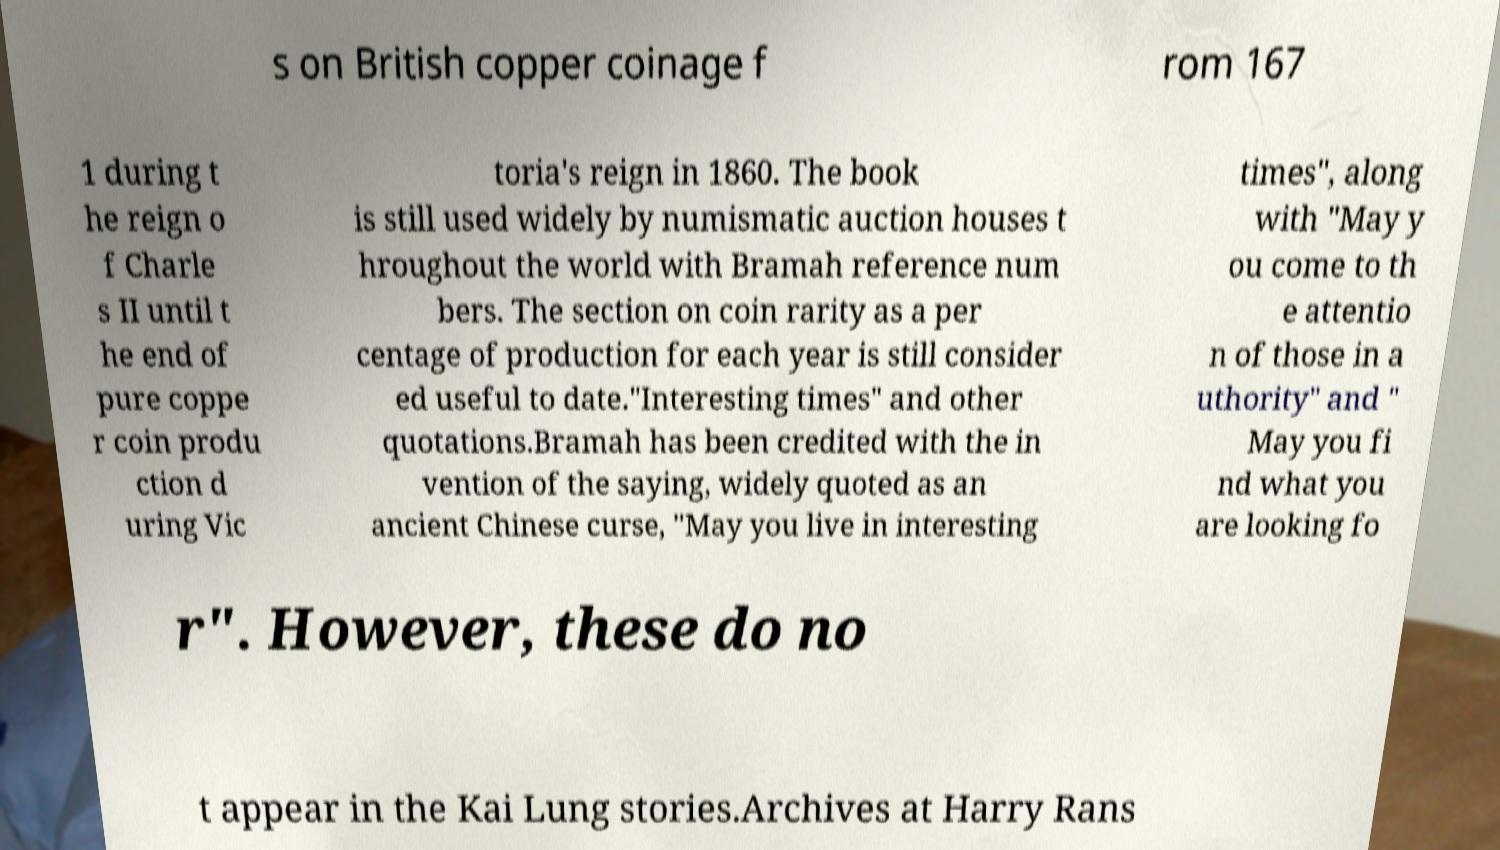For documentation purposes, I need the text within this image transcribed. Could you provide that? s on British copper coinage f rom 167 1 during t he reign o f Charle s II until t he end of pure coppe r coin produ ction d uring Vic toria's reign in 1860. The book is still used widely by numismatic auction houses t hroughout the world with Bramah reference num bers. The section on coin rarity as a per centage of production for each year is still consider ed useful to date."Interesting times" and other quotations.Bramah has been credited with the in vention of the saying, widely quoted as an ancient Chinese curse, "May you live in interesting times", along with "May y ou come to th e attentio n of those in a uthority" and " May you fi nd what you are looking fo r". However, these do no t appear in the Kai Lung stories.Archives at Harry Rans 